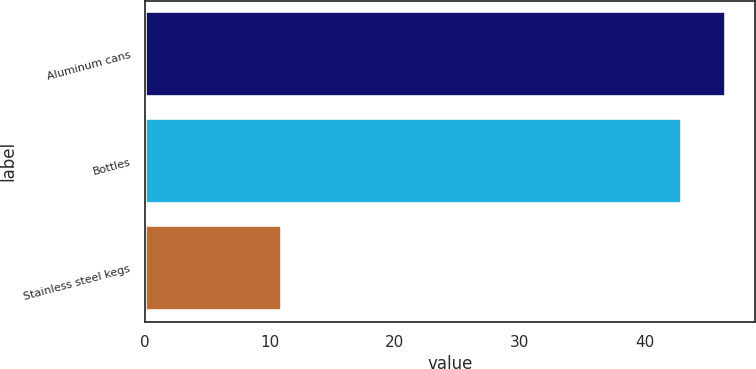<chart> <loc_0><loc_0><loc_500><loc_500><bar_chart><fcel>Aluminum cans<fcel>Bottles<fcel>Stainless steel kegs<nl><fcel>46.5<fcel>43<fcel>11<nl></chart> 